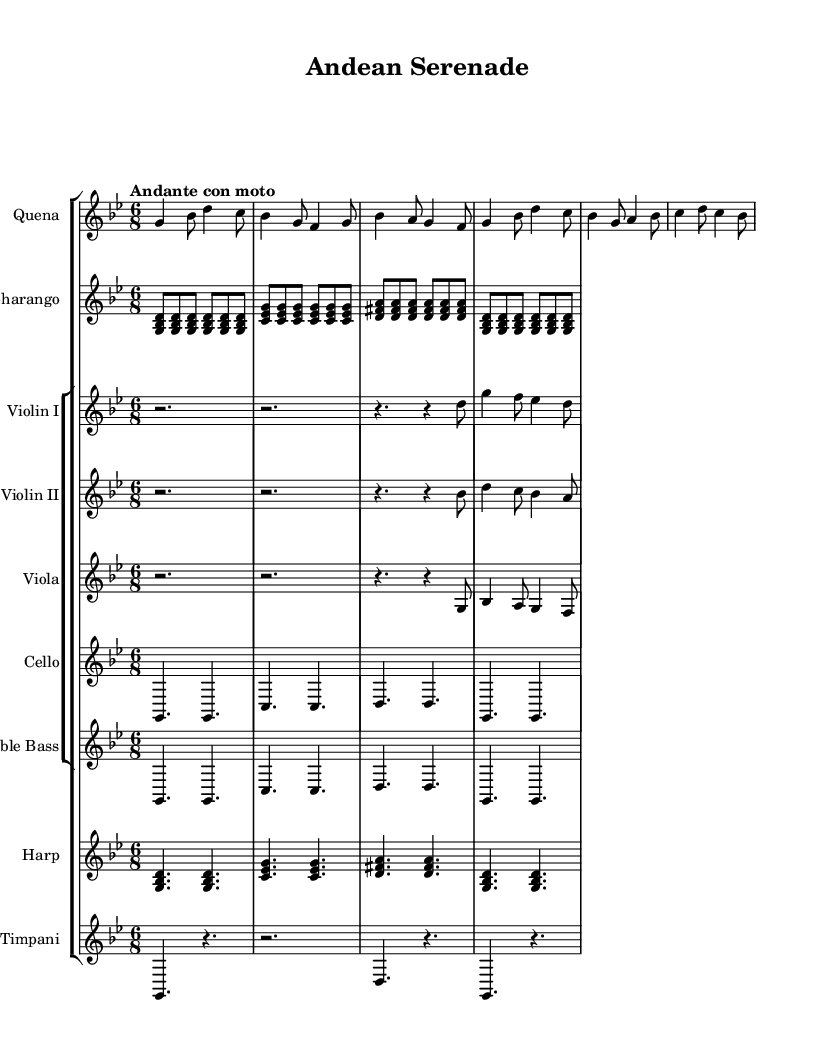What is the time signature of this music? The time signature appears at the beginning of the piece, indicated as 6/8, which means there are six eighth notes in each measure.
Answer: 6/8 What is the key signature of this music? The key signature is identified by the number of sharps or flats at the beginning of the staff. Here, there are two flats (B flat and E flat), indicating the key of G minor.
Answer: G minor What is the tempo marking? The tempo marking is located above the staff and indicates the intended speed of the piece. It states "Andante con moto," suggesting a moderately slow tempo with a little movement.
Answer: Andante con moto Which instrument plays the melody? The melody is often carried by the highest-pitched instrument, which here is the Quena. Observing its notes, it plays the leading melodic lines throughout.
Answer: Quena How many instruments are part of the orchestration? Counting the staves, we notice five distinct instruments: Quena, Charango, and a string section including Violin I, Violin II, Viola, Cello, Double Bass, as well as the Harp and Timpani. Therefore, the total is seven instruments.
Answer: Seven instruments What is the role of the Charango in this piece? The Charango, being a traditional Andean instrument, provides harmonic support and complements the melody. By looking at its music line, it's evident it plays a supporting rhythmic and harmonic role rather than the primary melody.
Answer: Harmonic support What rhythm pattern can be observed in the Timpani? Upon examining the Timpani part, it alternates between sustained notes and rests, establishing a contrasting rhythmic foundation for the other instruments and enhancing the overall texture of the piece.
Answer: Alternating sustained notes and rests 